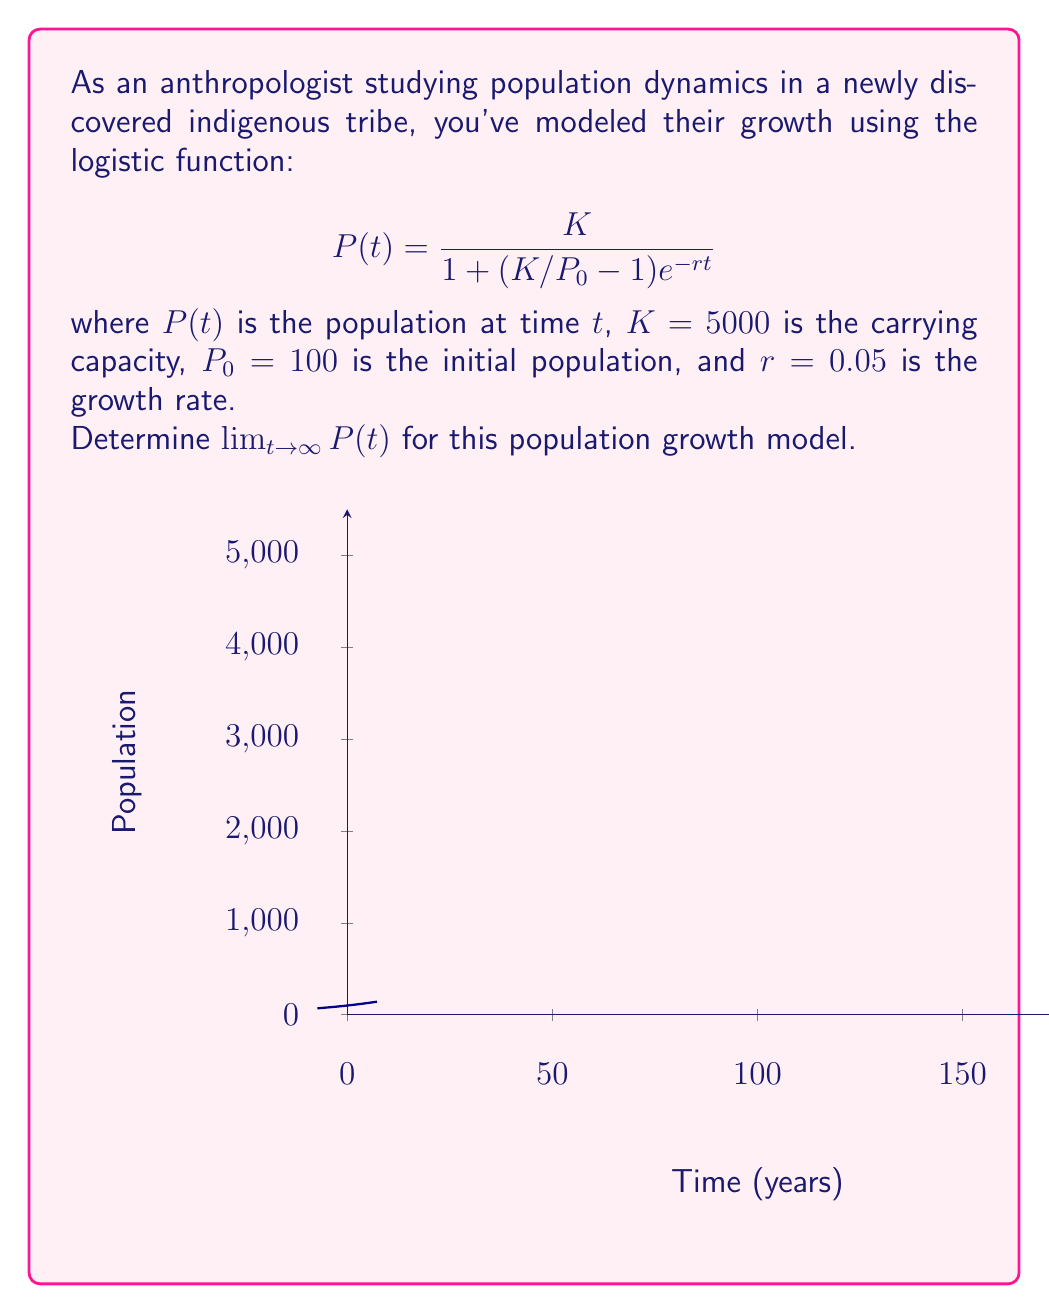Show me your answer to this math problem. To find the limit of $P(t)$ as $t$ approaches infinity, we'll follow these steps:

1) First, let's examine the given logistic function:
   $$P(t) = \frac{K}{1 + (K/P_0 - 1)e^{-rt}}$$

2) As $t \to \infty$, $e^{-rt} \to 0$ because $r > 0$. This is because:
   $$\lim_{t \to \infty} e^{-rt} = e^{-r(\infty)} = e^{-\infty} = 0$$

3) Therefore, as $t \to \infty$, the denominator of $P(t)$ approaches:
   $$1 + (K/P_0 - 1) \cdot 0 = 1$$

4) Thus, we can evaluate the limit:
   $$\lim_{t \to \infty} P(t) = \lim_{t \to \infty} \frac{K}{1 + (K/P_0 - 1)e^{-rt}} = \frac{K}{1} = K$$

5) We're given that $K = 5000$, so:
   $$\lim_{t \to \infty} P(t) = 5000$$

This result aligns with the biological interpretation of $K$ as the carrying capacity, which represents the maximum sustainable population in the given environment.
Answer: $5000$ 